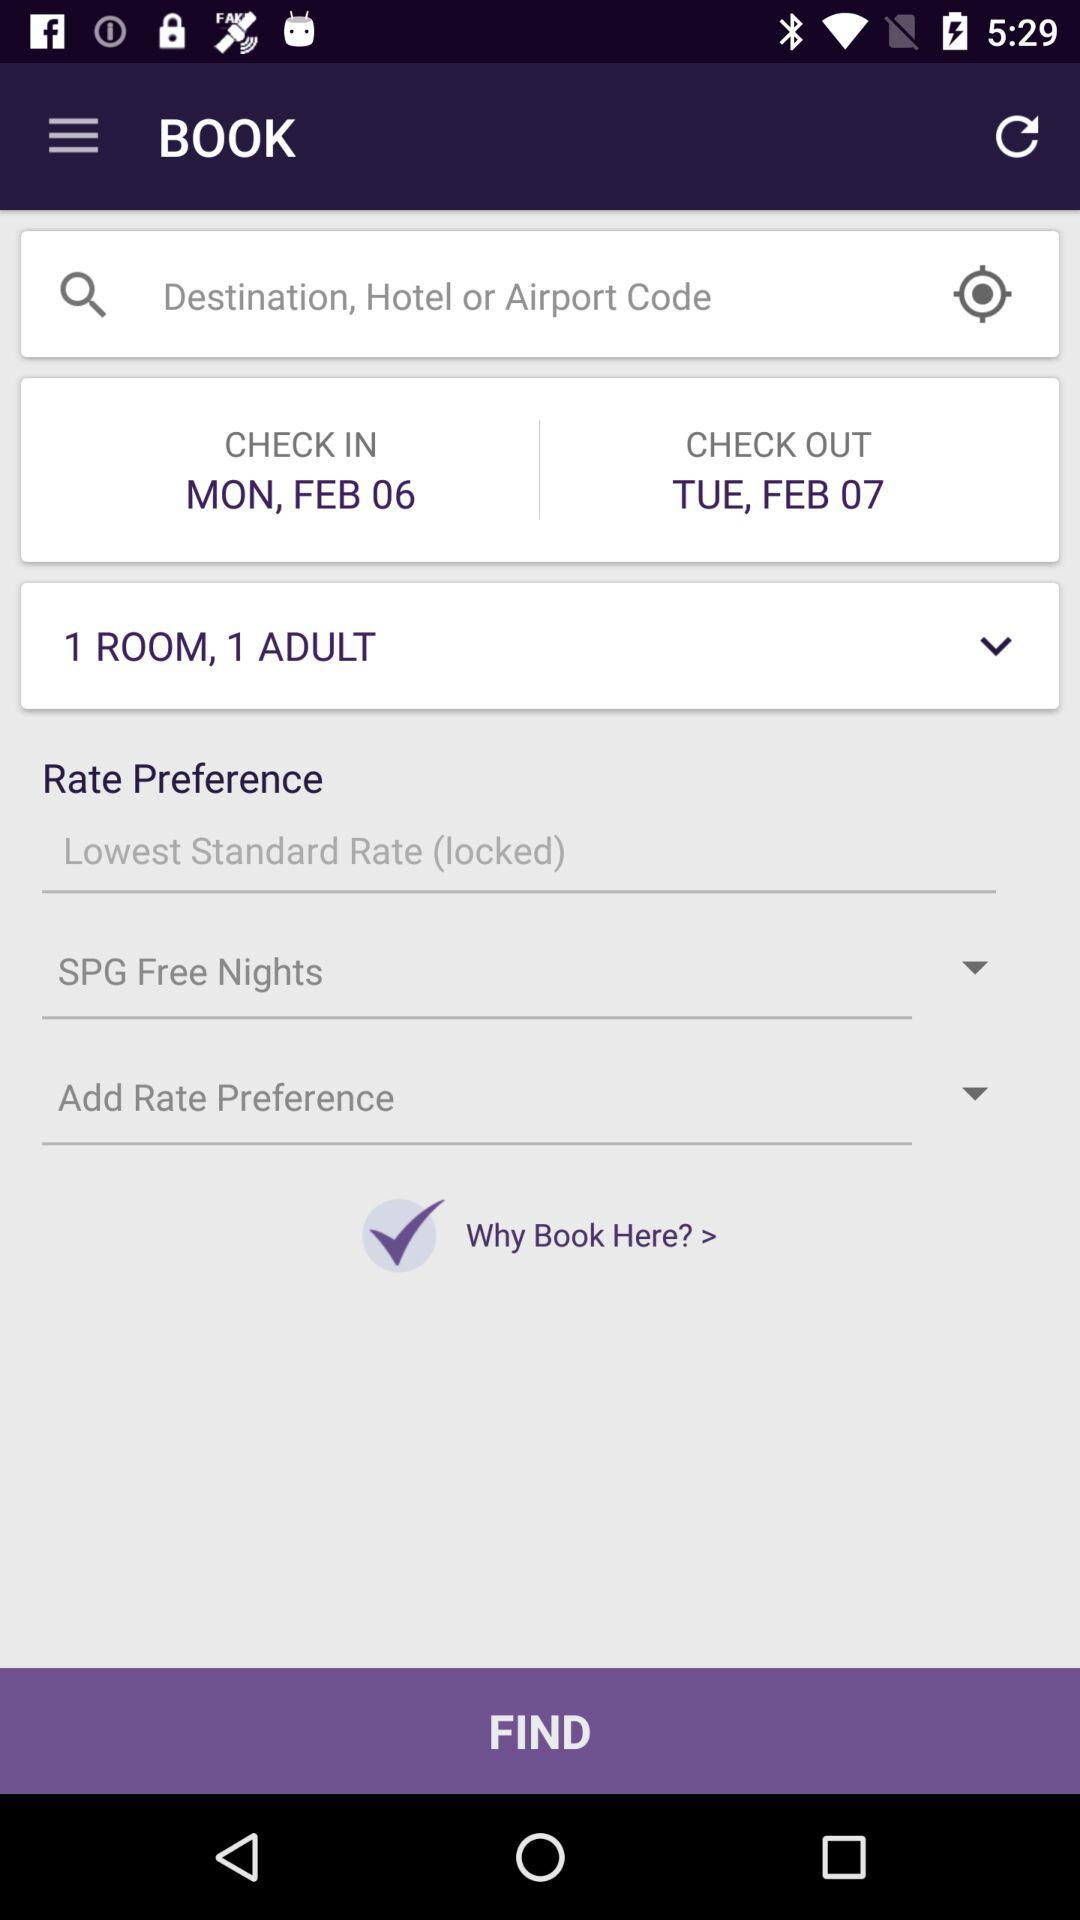What is the check out date? The check out date is Tuesday, February 07. 